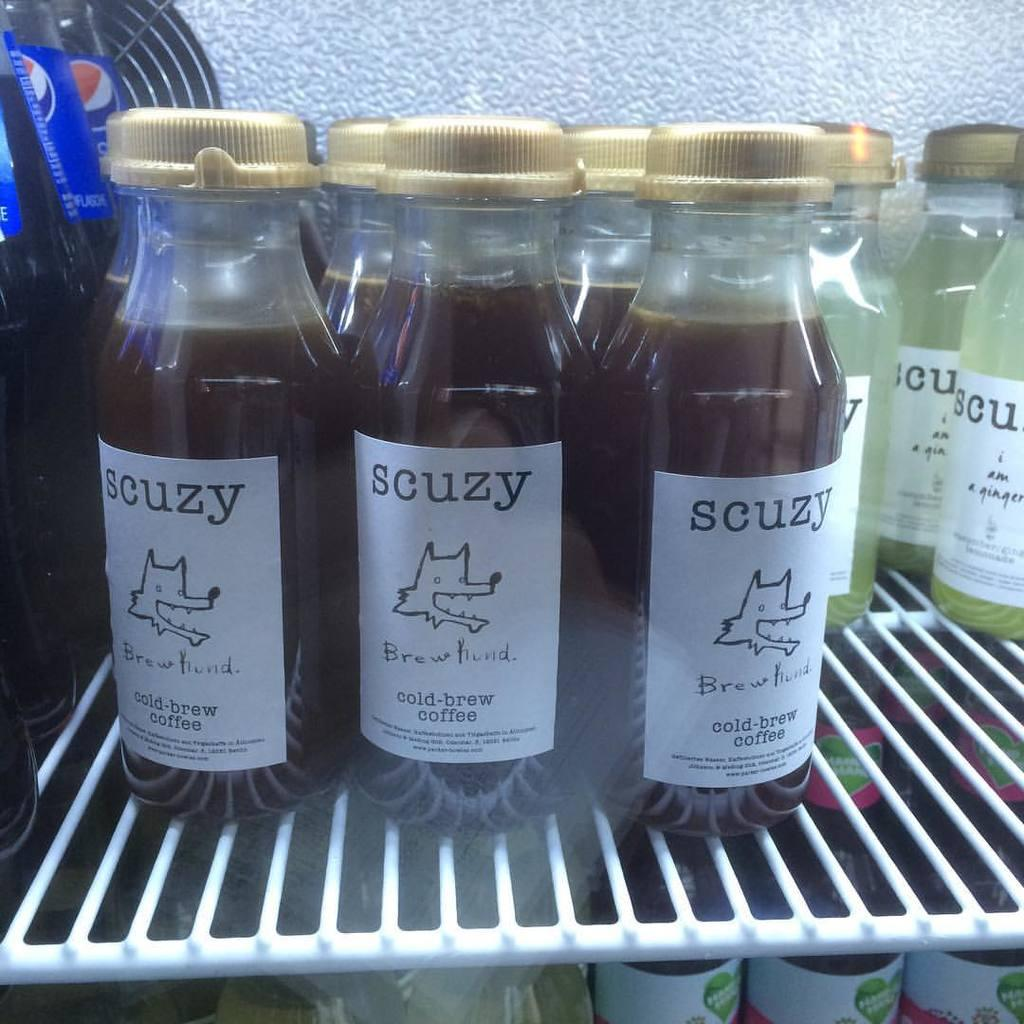Provide a one-sentence caption for the provided image. Several bottles of Scuzy cold-brew coffee are on a shelf next to some soda and other Scuzy brand drinks. 